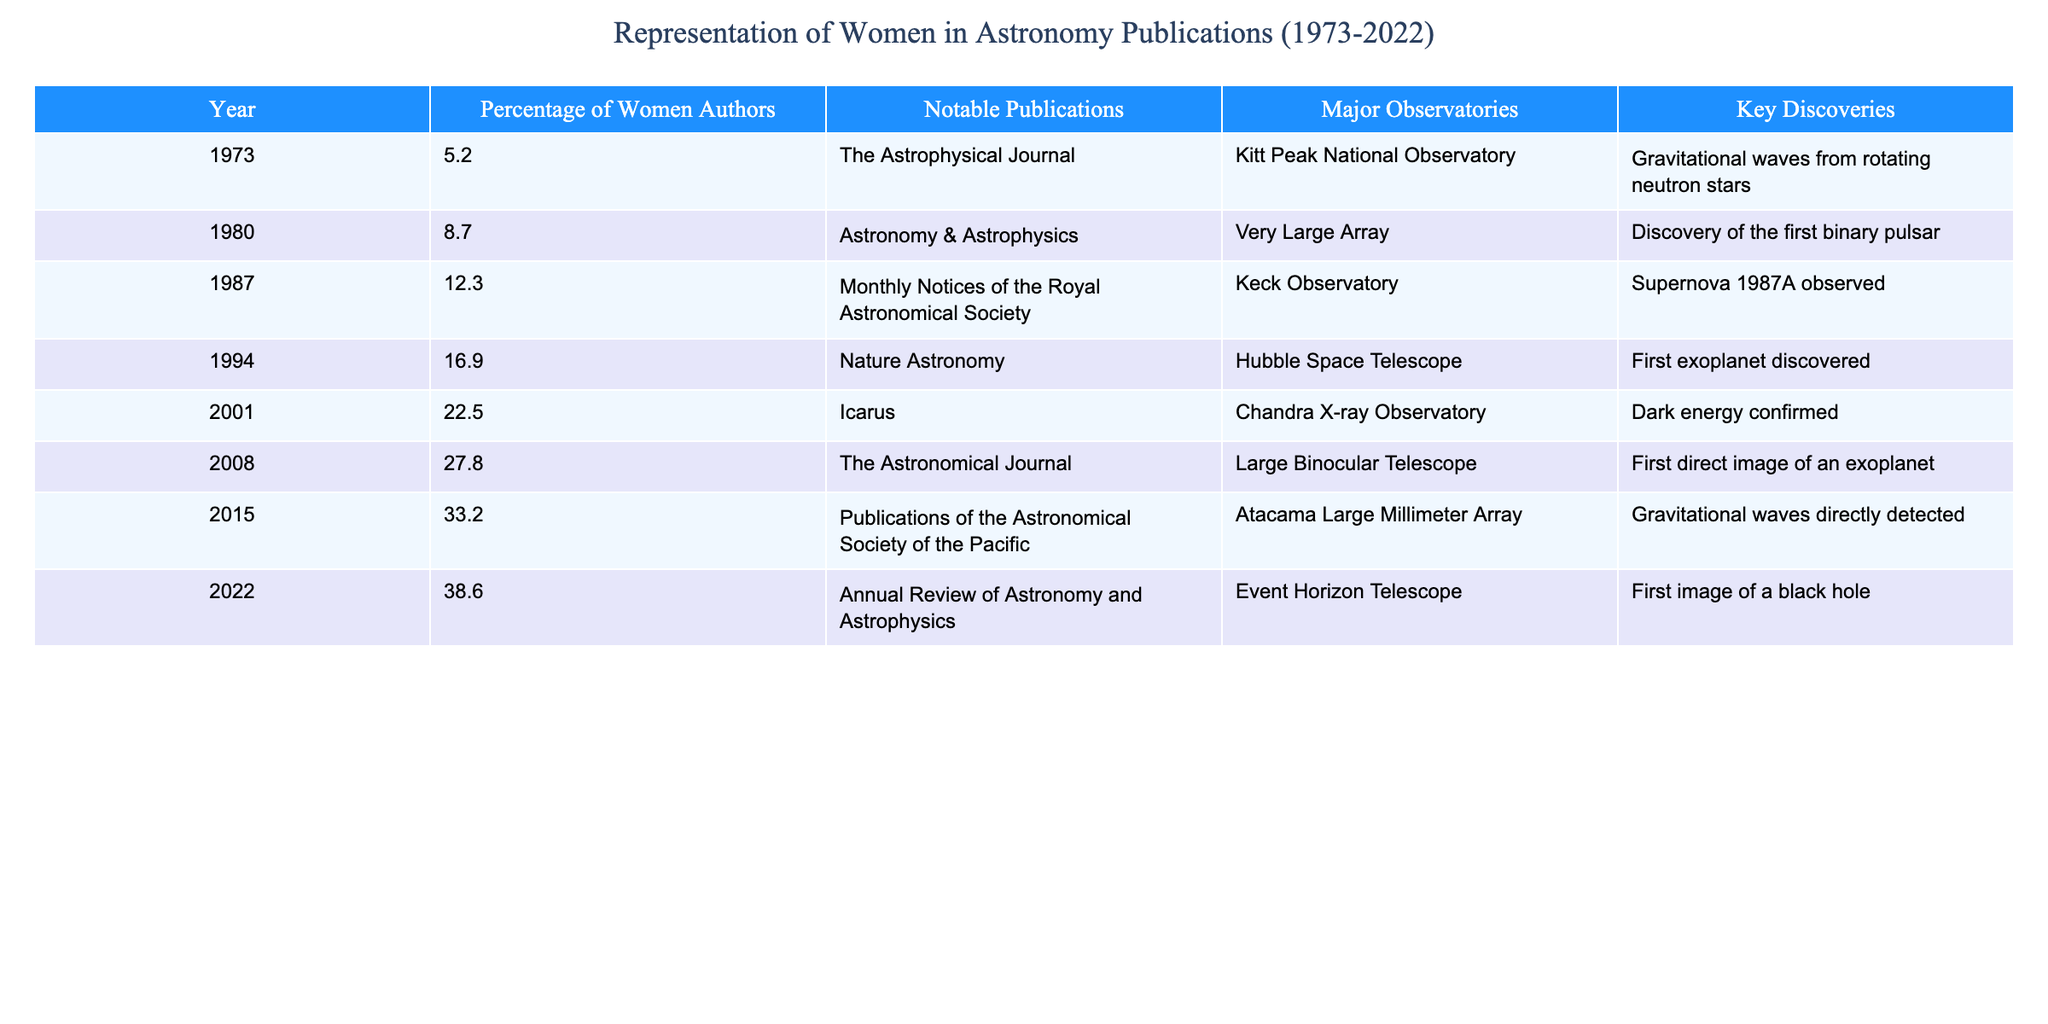What was the percentage of women authors in 1994? The table shows that in 1994, the percentage of women authors was listed directly under that year. According to the data, it is 16.9%.
Answer: 16.9% What notable publication was associated with the year 2008? By checking the table for the year 2008, the notable publication listed is "The Astronomical Journal."
Answer: The Astronomical Journal What is the trend in the percentage of women authors from 1973 to 2022? Observing the data from 1973 with 5.2% to 2022 with 38.6%, there is a clear upward trend in the percentage of women authors over these years.
Answer: An upward trend What was the key discovery in 2015, and how does it relate to the percentage of women authors? In 2015, the key discovery listed was "Gravitational waves directly detected," and the percentage of women authors that year was 33.2%. This shows that women's representation in publications coincided with significant scientific achievements.
Answer: Gravitational waves detected; 33.2% authorship How much did the percentage of women authors increase from 2001 to 2022? In 2001, the percentage was 22.5%, and in 2022 it was 38.6%. To calculate the increase: 38.6 - 22.5 = 16.1%.
Answer: 16.1% Which year had the highest representation of women among authors, and what was that percentage? The year with the highest percentage was 2022 at 38.6%. By reviewing the table, this value is clearly shown.
Answer: 2022; 38.6% Was the percentage of women authors in 1980 above or below 10%? The percentage for 1980 is 8.7%, which is below 10%. This can be confirmed directly from the table.
Answer: Below How does the percentage of women authors in 1987 compare to that in 1994? In 1987, the percentage of women authors was 12.3%, while in 1994 it was 16.9%. So, 16.9% - 12.3% = 4.6% indicates an increase.
Answer: 4.6% increase What is the average percentage of women authors from 2001 to 2022? The percentages from 2001 to 2022 are 22.5%, 27.8%, 33.2%, and 38.6%. Calculating the average: (22.5 + 27.8 + 33.2 + 38.6) / 4 = 30.53%.
Answer: 30.53% What significant trend is noted in the percentage of women authors over the decades? The table reflects a significant increase in the percentage of women authors from 5.2% in 1973 to 38.6% in 2022, indicating progress in gender representation in the field.
Answer: Increased representation 